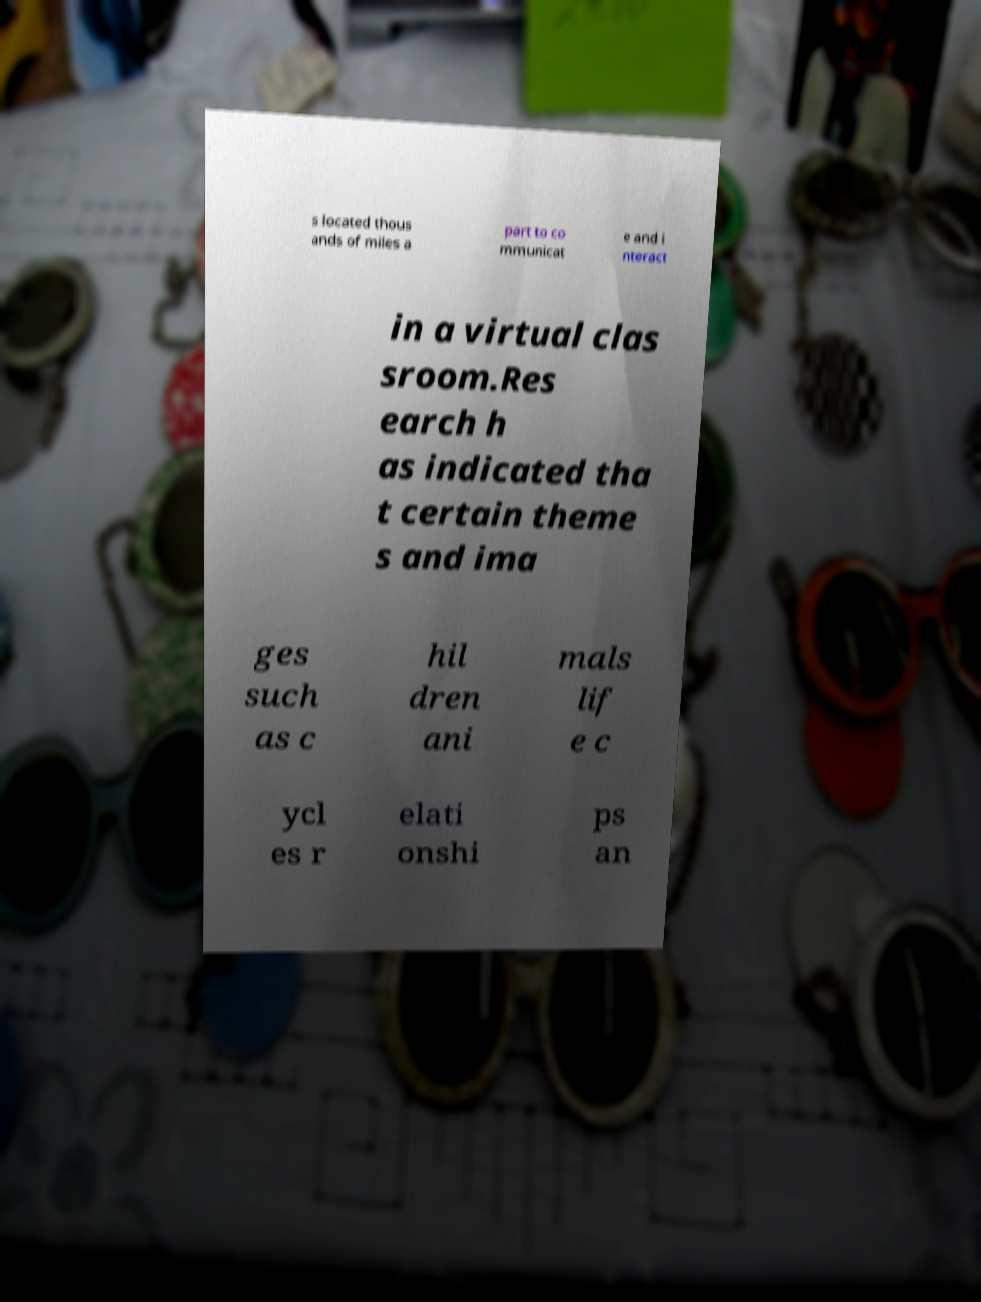Could you extract and type out the text from this image? s located thous ands of miles a part to co mmunicat e and i nteract in a virtual clas sroom.Res earch h as indicated tha t certain theme s and ima ges such as c hil dren ani mals lif e c ycl es r elati onshi ps an 